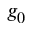<formula> <loc_0><loc_0><loc_500><loc_500>g _ { 0 }</formula> 